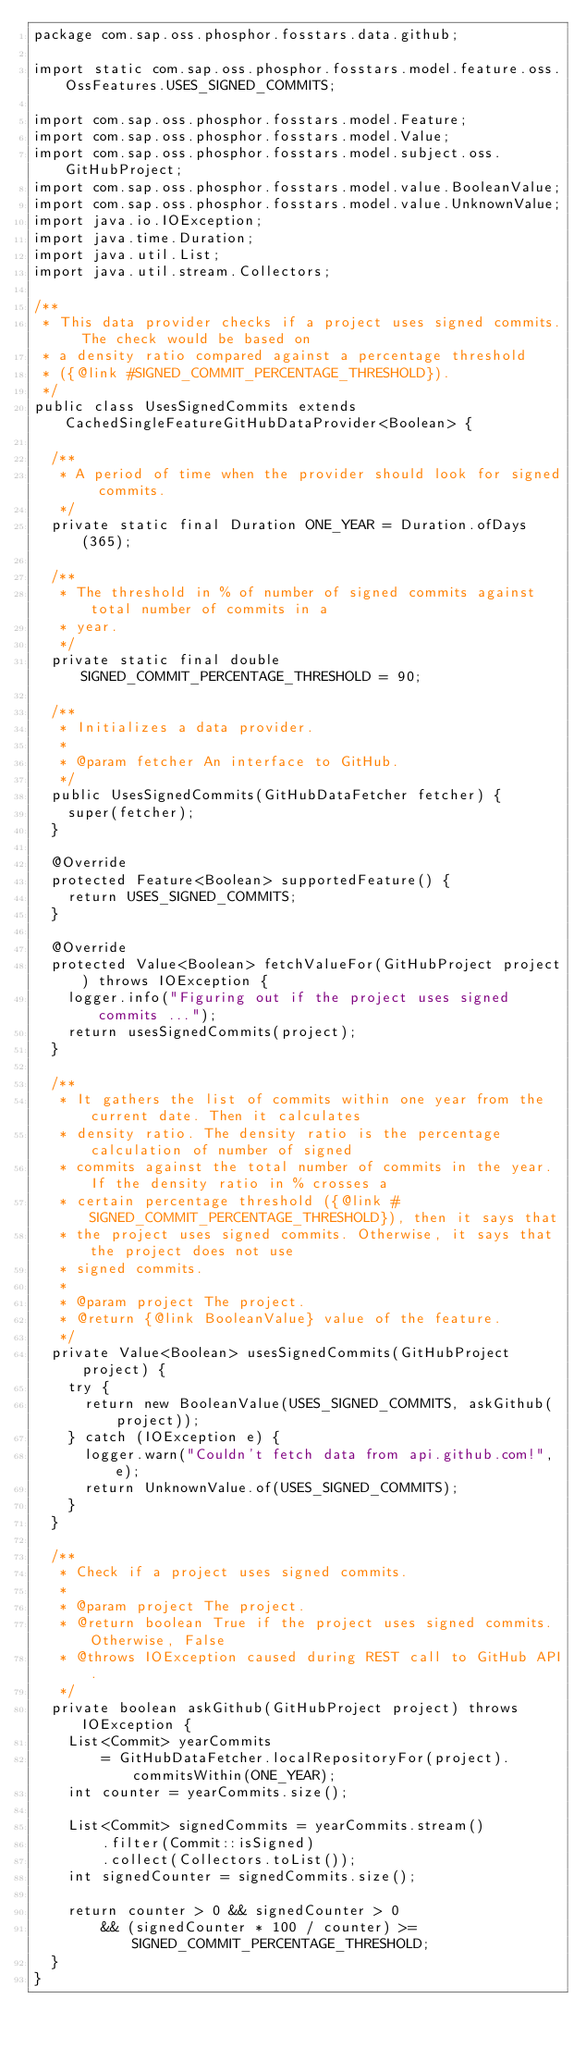<code> <loc_0><loc_0><loc_500><loc_500><_Java_>package com.sap.oss.phosphor.fosstars.data.github;

import static com.sap.oss.phosphor.fosstars.model.feature.oss.OssFeatures.USES_SIGNED_COMMITS;

import com.sap.oss.phosphor.fosstars.model.Feature;
import com.sap.oss.phosphor.fosstars.model.Value;
import com.sap.oss.phosphor.fosstars.model.subject.oss.GitHubProject;
import com.sap.oss.phosphor.fosstars.model.value.BooleanValue;
import com.sap.oss.phosphor.fosstars.model.value.UnknownValue;
import java.io.IOException;
import java.time.Duration;
import java.util.List;
import java.util.stream.Collectors;

/**
 * This data provider checks if a project uses signed commits. The check would be based on
 * a density ratio compared against a percentage threshold
 * ({@link #SIGNED_COMMIT_PERCENTAGE_THRESHOLD}).
 */
public class UsesSignedCommits extends CachedSingleFeatureGitHubDataProvider<Boolean> {

  /**
   * A period of time when the provider should look for signed commits.
   */
  private static final Duration ONE_YEAR = Duration.ofDays(365);

  /**
   * The threshold in % of number of signed commits against total number of commits in a
   * year.
   */
  private static final double SIGNED_COMMIT_PERCENTAGE_THRESHOLD = 90;

  /**
   * Initializes a data provider.
   *
   * @param fetcher An interface to GitHub.
   */
  public UsesSignedCommits(GitHubDataFetcher fetcher) {
    super(fetcher);
  }

  @Override
  protected Feature<Boolean> supportedFeature() {
    return USES_SIGNED_COMMITS;
  }

  @Override
  protected Value<Boolean> fetchValueFor(GitHubProject project) throws IOException {
    logger.info("Figuring out if the project uses signed commits ...");
    return usesSignedCommits(project);
  }

  /**
   * It gathers the list of commits within one year from the current date. Then it calculates
   * density ratio. The density ratio is the percentage calculation of number of signed
   * commits against the total number of commits in the year. If the density ratio in % crosses a
   * certain percentage threshold ({@link #SIGNED_COMMIT_PERCENTAGE_THRESHOLD}), then it says that
   * the project uses signed commits. Otherwise, it says that the project does not use
   * signed commits.
   *
   * @param project The project.
   * @return {@link BooleanValue} value of the feature.
   */
  private Value<Boolean> usesSignedCommits(GitHubProject project) {
    try {
      return new BooleanValue(USES_SIGNED_COMMITS, askGithub(project));
    } catch (IOException e) {
      logger.warn("Couldn't fetch data from api.github.com!", e);
      return UnknownValue.of(USES_SIGNED_COMMITS);
    }
  }

  /**
   * Check if a project uses signed commits.
   *
   * @param project The project.
   * @return boolean True if the project uses signed commits. Otherwise, False
   * @throws IOException caused during REST call to GitHub API.
   */  
  private boolean askGithub(GitHubProject project) throws IOException {
    List<Commit> yearCommits
        = GitHubDataFetcher.localRepositoryFor(project).commitsWithin(ONE_YEAR);
    int counter = yearCommits.size();

    List<Commit> signedCommits = yearCommits.stream()
        .filter(Commit::isSigned)
        .collect(Collectors.toList());
    int signedCounter = signedCommits.size();

    return counter > 0 && signedCounter > 0
        && (signedCounter * 100 / counter) >= SIGNED_COMMIT_PERCENTAGE_THRESHOLD;
  }
}</code> 